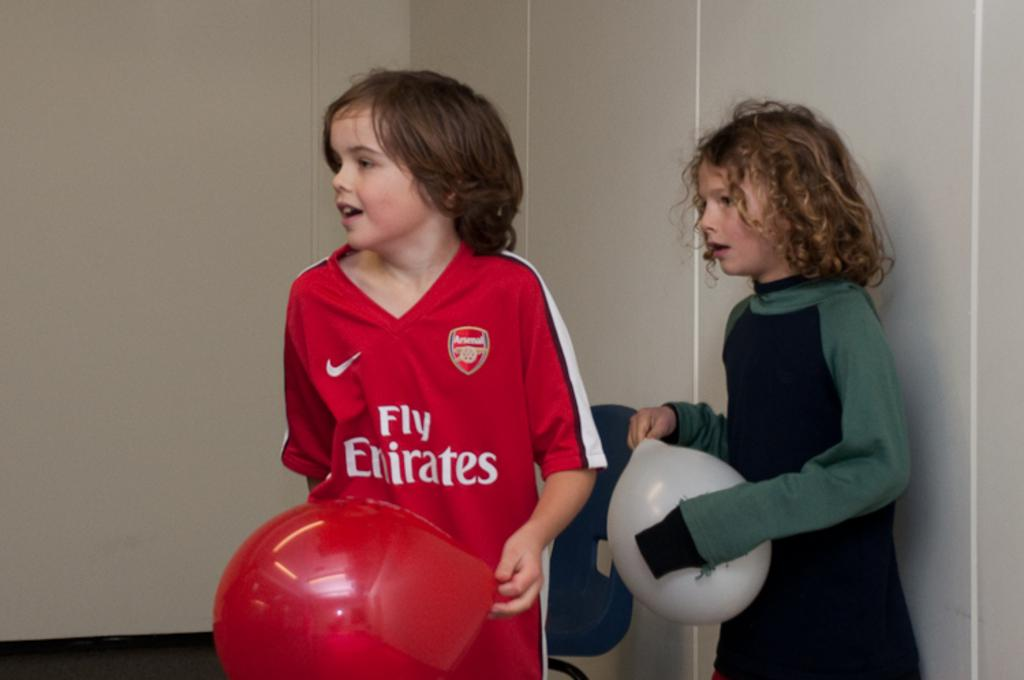<image>
Relay a brief, clear account of the picture shown. Two kids, one of whom is wearing a Fly Emirates shirt. 